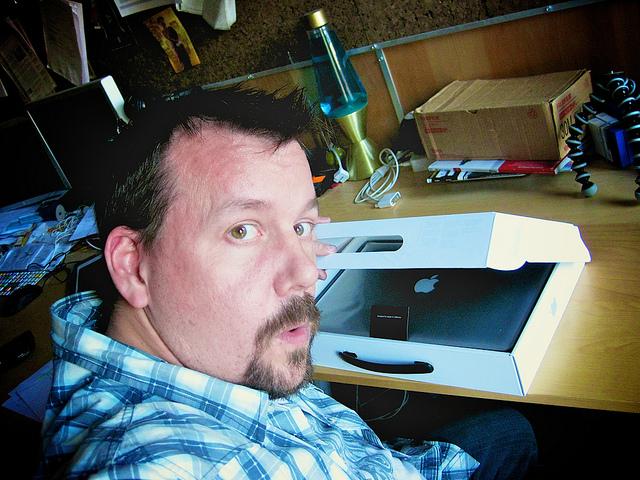What color is the lava lamp?
Be succinct. Blue. What is the man opening?
Quick response, please. Laptop. What type of laptop is that?
Keep it brief. Apple. 